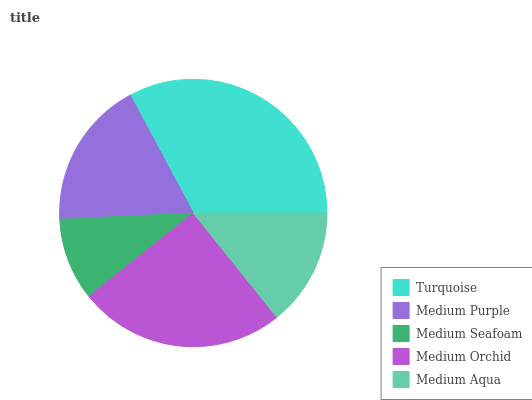Is Medium Seafoam the minimum?
Answer yes or no. Yes. Is Turquoise the maximum?
Answer yes or no. Yes. Is Medium Purple the minimum?
Answer yes or no. No. Is Medium Purple the maximum?
Answer yes or no. No. Is Turquoise greater than Medium Purple?
Answer yes or no. Yes. Is Medium Purple less than Turquoise?
Answer yes or no. Yes. Is Medium Purple greater than Turquoise?
Answer yes or no. No. Is Turquoise less than Medium Purple?
Answer yes or no. No. Is Medium Purple the high median?
Answer yes or no. Yes. Is Medium Purple the low median?
Answer yes or no. Yes. Is Medium Orchid the high median?
Answer yes or no. No. Is Medium Seafoam the low median?
Answer yes or no. No. 